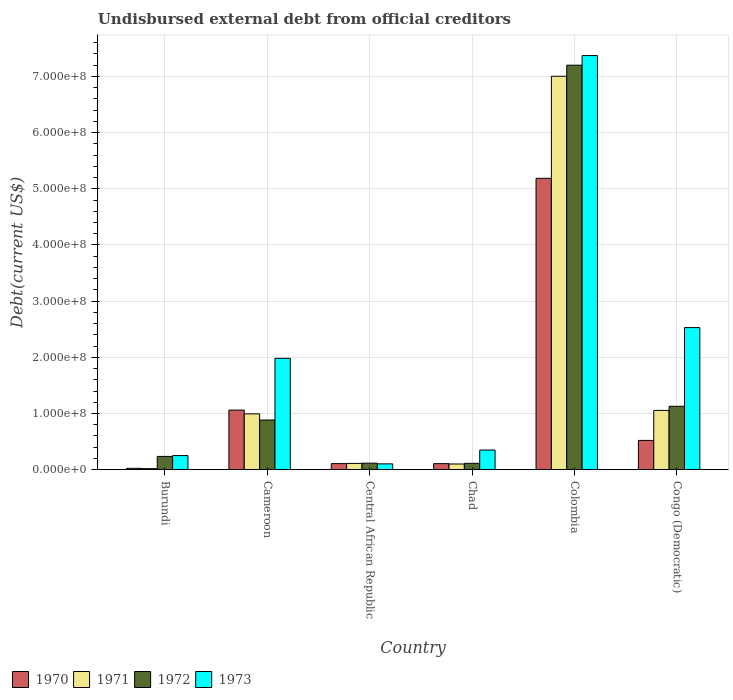How many different coloured bars are there?
Keep it short and to the point. 4. Are the number of bars per tick equal to the number of legend labels?
Your answer should be very brief. Yes. Are the number of bars on each tick of the X-axis equal?
Offer a terse response. Yes. How many bars are there on the 3rd tick from the right?
Your answer should be very brief. 4. What is the label of the 1st group of bars from the left?
Provide a short and direct response. Burundi. What is the total debt in 1972 in Chad?
Provide a succinct answer. 1.14e+07. Across all countries, what is the maximum total debt in 1971?
Your answer should be very brief. 7.00e+08. Across all countries, what is the minimum total debt in 1971?
Provide a short and direct response. 1.93e+06. In which country was the total debt in 1973 maximum?
Offer a terse response. Colombia. In which country was the total debt in 1971 minimum?
Your answer should be compact. Burundi. What is the total total debt in 1972 in the graph?
Your answer should be very brief. 9.68e+08. What is the difference between the total debt in 1972 in Burundi and that in Chad?
Your answer should be compact. 1.23e+07. What is the difference between the total debt in 1972 in Burundi and the total debt in 1973 in Cameroon?
Give a very brief answer. -1.75e+08. What is the average total debt in 1971 per country?
Your answer should be very brief. 1.55e+08. What is the difference between the total debt of/in 1973 and total debt of/in 1970 in Central African Republic?
Offer a terse response. -4.80e+05. In how many countries, is the total debt in 1972 greater than 360000000 US$?
Provide a short and direct response. 1. What is the ratio of the total debt in 1973 in Cameroon to that in Colombia?
Your answer should be compact. 0.27. Is the difference between the total debt in 1973 in Cameroon and Congo (Democratic) greater than the difference between the total debt in 1970 in Cameroon and Congo (Democratic)?
Your answer should be compact. No. What is the difference between the highest and the second highest total debt in 1972?
Offer a very short reply. 6.31e+08. What is the difference between the highest and the lowest total debt in 1973?
Keep it short and to the point. 7.27e+08. In how many countries, is the total debt in 1973 greater than the average total debt in 1973 taken over all countries?
Make the answer very short. 2. Is it the case that in every country, the sum of the total debt in 1973 and total debt in 1971 is greater than the sum of total debt in 1970 and total debt in 1972?
Your answer should be compact. No. Is it the case that in every country, the sum of the total debt in 1971 and total debt in 1973 is greater than the total debt in 1972?
Your answer should be compact. Yes. How many bars are there?
Offer a very short reply. 24. Are the values on the major ticks of Y-axis written in scientific E-notation?
Offer a terse response. Yes. Does the graph contain grids?
Offer a very short reply. Yes. Where does the legend appear in the graph?
Provide a succinct answer. Bottom left. How many legend labels are there?
Keep it short and to the point. 4. How are the legend labels stacked?
Offer a terse response. Horizontal. What is the title of the graph?
Offer a terse response. Undisbursed external debt from official creditors. Does "1973" appear as one of the legend labels in the graph?
Give a very brief answer. Yes. What is the label or title of the X-axis?
Offer a terse response. Country. What is the label or title of the Y-axis?
Ensure brevity in your answer.  Debt(current US$). What is the Debt(current US$) in 1970 in Burundi?
Your response must be concise. 2.42e+06. What is the Debt(current US$) in 1971 in Burundi?
Offer a very short reply. 1.93e+06. What is the Debt(current US$) in 1972 in Burundi?
Provide a succinct answer. 2.37e+07. What is the Debt(current US$) of 1973 in Burundi?
Keep it short and to the point. 2.51e+07. What is the Debt(current US$) in 1970 in Cameroon?
Your response must be concise. 1.06e+08. What is the Debt(current US$) of 1971 in Cameroon?
Your answer should be very brief. 9.94e+07. What is the Debt(current US$) in 1972 in Cameroon?
Provide a succinct answer. 8.84e+07. What is the Debt(current US$) of 1973 in Cameroon?
Offer a terse response. 1.98e+08. What is the Debt(current US$) of 1970 in Central African Republic?
Offer a very short reply. 1.08e+07. What is the Debt(current US$) of 1971 in Central African Republic?
Offer a very short reply. 1.12e+07. What is the Debt(current US$) in 1972 in Central African Republic?
Give a very brief answer. 1.16e+07. What is the Debt(current US$) in 1973 in Central African Republic?
Offer a terse response. 1.04e+07. What is the Debt(current US$) of 1970 in Chad?
Make the answer very short. 1.08e+07. What is the Debt(current US$) in 1971 in Chad?
Your answer should be very brief. 1.02e+07. What is the Debt(current US$) of 1972 in Chad?
Give a very brief answer. 1.14e+07. What is the Debt(current US$) of 1973 in Chad?
Ensure brevity in your answer.  3.50e+07. What is the Debt(current US$) of 1970 in Colombia?
Keep it short and to the point. 5.19e+08. What is the Debt(current US$) of 1971 in Colombia?
Keep it short and to the point. 7.00e+08. What is the Debt(current US$) of 1972 in Colombia?
Keep it short and to the point. 7.20e+08. What is the Debt(current US$) in 1973 in Colombia?
Make the answer very short. 7.37e+08. What is the Debt(current US$) of 1970 in Congo (Democratic)?
Ensure brevity in your answer.  5.21e+07. What is the Debt(current US$) in 1971 in Congo (Democratic)?
Give a very brief answer. 1.06e+08. What is the Debt(current US$) of 1972 in Congo (Democratic)?
Offer a very short reply. 1.13e+08. What is the Debt(current US$) in 1973 in Congo (Democratic)?
Your answer should be compact. 2.53e+08. Across all countries, what is the maximum Debt(current US$) in 1970?
Give a very brief answer. 5.19e+08. Across all countries, what is the maximum Debt(current US$) in 1971?
Your response must be concise. 7.00e+08. Across all countries, what is the maximum Debt(current US$) of 1972?
Keep it short and to the point. 7.20e+08. Across all countries, what is the maximum Debt(current US$) in 1973?
Your answer should be compact. 7.37e+08. Across all countries, what is the minimum Debt(current US$) of 1970?
Make the answer very short. 2.42e+06. Across all countries, what is the minimum Debt(current US$) of 1971?
Offer a terse response. 1.93e+06. Across all countries, what is the minimum Debt(current US$) of 1972?
Provide a short and direct response. 1.14e+07. Across all countries, what is the minimum Debt(current US$) of 1973?
Provide a succinct answer. 1.04e+07. What is the total Debt(current US$) in 1970 in the graph?
Offer a very short reply. 7.01e+08. What is the total Debt(current US$) of 1971 in the graph?
Make the answer very short. 9.28e+08. What is the total Debt(current US$) in 1972 in the graph?
Provide a short and direct response. 9.68e+08. What is the total Debt(current US$) of 1973 in the graph?
Offer a very short reply. 1.26e+09. What is the difference between the Debt(current US$) in 1970 in Burundi and that in Cameroon?
Give a very brief answer. -1.04e+08. What is the difference between the Debt(current US$) in 1971 in Burundi and that in Cameroon?
Offer a very short reply. -9.74e+07. What is the difference between the Debt(current US$) in 1972 in Burundi and that in Cameroon?
Make the answer very short. -6.48e+07. What is the difference between the Debt(current US$) of 1973 in Burundi and that in Cameroon?
Your response must be concise. -1.73e+08. What is the difference between the Debt(current US$) of 1970 in Burundi and that in Central African Republic?
Provide a short and direct response. -8.42e+06. What is the difference between the Debt(current US$) in 1971 in Burundi and that in Central African Republic?
Your answer should be compact. -9.26e+06. What is the difference between the Debt(current US$) in 1972 in Burundi and that in Central African Republic?
Provide a succinct answer. 1.20e+07. What is the difference between the Debt(current US$) in 1973 in Burundi and that in Central African Republic?
Make the answer very short. 1.47e+07. What is the difference between the Debt(current US$) of 1970 in Burundi and that in Chad?
Provide a short and direct response. -8.37e+06. What is the difference between the Debt(current US$) in 1971 in Burundi and that in Chad?
Give a very brief answer. -8.22e+06. What is the difference between the Debt(current US$) in 1972 in Burundi and that in Chad?
Give a very brief answer. 1.23e+07. What is the difference between the Debt(current US$) in 1973 in Burundi and that in Chad?
Provide a succinct answer. -9.88e+06. What is the difference between the Debt(current US$) in 1970 in Burundi and that in Colombia?
Keep it short and to the point. -5.16e+08. What is the difference between the Debt(current US$) in 1971 in Burundi and that in Colombia?
Your response must be concise. -6.98e+08. What is the difference between the Debt(current US$) in 1972 in Burundi and that in Colombia?
Your answer should be very brief. -6.96e+08. What is the difference between the Debt(current US$) in 1973 in Burundi and that in Colombia?
Your answer should be compact. -7.12e+08. What is the difference between the Debt(current US$) of 1970 in Burundi and that in Congo (Democratic)?
Offer a very short reply. -4.97e+07. What is the difference between the Debt(current US$) of 1971 in Burundi and that in Congo (Democratic)?
Your response must be concise. -1.04e+08. What is the difference between the Debt(current US$) of 1972 in Burundi and that in Congo (Democratic)?
Offer a very short reply. -8.92e+07. What is the difference between the Debt(current US$) of 1973 in Burundi and that in Congo (Democratic)?
Offer a terse response. -2.28e+08. What is the difference between the Debt(current US$) of 1970 in Cameroon and that in Central African Republic?
Provide a short and direct response. 9.52e+07. What is the difference between the Debt(current US$) in 1971 in Cameroon and that in Central African Republic?
Your answer should be compact. 8.82e+07. What is the difference between the Debt(current US$) in 1972 in Cameroon and that in Central African Republic?
Make the answer very short. 7.68e+07. What is the difference between the Debt(current US$) of 1973 in Cameroon and that in Central African Republic?
Offer a terse response. 1.88e+08. What is the difference between the Debt(current US$) in 1970 in Cameroon and that in Chad?
Your answer should be compact. 9.53e+07. What is the difference between the Debt(current US$) in 1971 in Cameroon and that in Chad?
Keep it short and to the point. 8.92e+07. What is the difference between the Debt(current US$) of 1972 in Cameroon and that in Chad?
Offer a very short reply. 7.71e+07. What is the difference between the Debt(current US$) in 1973 in Cameroon and that in Chad?
Give a very brief answer. 1.63e+08. What is the difference between the Debt(current US$) of 1970 in Cameroon and that in Colombia?
Your answer should be very brief. -4.12e+08. What is the difference between the Debt(current US$) of 1971 in Cameroon and that in Colombia?
Ensure brevity in your answer.  -6.01e+08. What is the difference between the Debt(current US$) in 1972 in Cameroon and that in Colombia?
Your answer should be compact. -6.31e+08. What is the difference between the Debt(current US$) in 1973 in Cameroon and that in Colombia?
Offer a very short reply. -5.39e+08. What is the difference between the Debt(current US$) of 1970 in Cameroon and that in Congo (Democratic)?
Provide a succinct answer. 5.40e+07. What is the difference between the Debt(current US$) in 1971 in Cameroon and that in Congo (Democratic)?
Keep it short and to the point. -6.17e+06. What is the difference between the Debt(current US$) in 1972 in Cameroon and that in Congo (Democratic)?
Keep it short and to the point. -2.44e+07. What is the difference between the Debt(current US$) in 1973 in Cameroon and that in Congo (Democratic)?
Provide a succinct answer. -5.47e+07. What is the difference between the Debt(current US$) of 1970 in Central African Republic and that in Chad?
Keep it short and to the point. 5.50e+04. What is the difference between the Debt(current US$) in 1971 in Central African Republic and that in Chad?
Keep it short and to the point. 1.04e+06. What is the difference between the Debt(current US$) of 1972 in Central African Republic and that in Chad?
Offer a very short reply. 2.79e+05. What is the difference between the Debt(current US$) of 1973 in Central African Republic and that in Chad?
Offer a very short reply. -2.46e+07. What is the difference between the Debt(current US$) of 1970 in Central African Republic and that in Colombia?
Offer a very short reply. -5.08e+08. What is the difference between the Debt(current US$) of 1971 in Central African Republic and that in Colombia?
Provide a short and direct response. -6.89e+08. What is the difference between the Debt(current US$) of 1972 in Central African Republic and that in Colombia?
Your answer should be compact. -7.08e+08. What is the difference between the Debt(current US$) of 1973 in Central African Republic and that in Colombia?
Provide a succinct answer. -7.27e+08. What is the difference between the Debt(current US$) of 1970 in Central African Republic and that in Congo (Democratic)?
Keep it short and to the point. -4.13e+07. What is the difference between the Debt(current US$) in 1971 in Central African Republic and that in Congo (Democratic)?
Ensure brevity in your answer.  -9.44e+07. What is the difference between the Debt(current US$) in 1972 in Central African Republic and that in Congo (Democratic)?
Your response must be concise. -1.01e+08. What is the difference between the Debt(current US$) of 1973 in Central African Republic and that in Congo (Democratic)?
Offer a very short reply. -2.43e+08. What is the difference between the Debt(current US$) of 1970 in Chad and that in Colombia?
Give a very brief answer. -5.08e+08. What is the difference between the Debt(current US$) in 1971 in Chad and that in Colombia?
Give a very brief answer. -6.90e+08. What is the difference between the Debt(current US$) in 1972 in Chad and that in Colombia?
Your response must be concise. -7.09e+08. What is the difference between the Debt(current US$) of 1973 in Chad and that in Colombia?
Offer a terse response. -7.02e+08. What is the difference between the Debt(current US$) of 1970 in Chad and that in Congo (Democratic)?
Your answer should be compact. -4.13e+07. What is the difference between the Debt(current US$) in 1971 in Chad and that in Congo (Democratic)?
Keep it short and to the point. -9.54e+07. What is the difference between the Debt(current US$) of 1972 in Chad and that in Congo (Democratic)?
Give a very brief answer. -1.02e+08. What is the difference between the Debt(current US$) in 1973 in Chad and that in Congo (Democratic)?
Your answer should be compact. -2.18e+08. What is the difference between the Debt(current US$) in 1970 in Colombia and that in Congo (Democratic)?
Make the answer very short. 4.66e+08. What is the difference between the Debt(current US$) of 1971 in Colombia and that in Congo (Democratic)?
Ensure brevity in your answer.  5.95e+08. What is the difference between the Debt(current US$) in 1972 in Colombia and that in Congo (Democratic)?
Your answer should be compact. 6.07e+08. What is the difference between the Debt(current US$) in 1973 in Colombia and that in Congo (Democratic)?
Offer a terse response. 4.84e+08. What is the difference between the Debt(current US$) of 1970 in Burundi and the Debt(current US$) of 1971 in Cameroon?
Offer a very short reply. -9.69e+07. What is the difference between the Debt(current US$) in 1970 in Burundi and the Debt(current US$) in 1972 in Cameroon?
Ensure brevity in your answer.  -8.60e+07. What is the difference between the Debt(current US$) in 1970 in Burundi and the Debt(current US$) in 1973 in Cameroon?
Your answer should be very brief. -1.96e+08. What is the difference between the Debt(current US$) in 1971 in Burundi and the Debt(current US$) in 1972 in Cameroon?
Your response must be concise. -8.65e+07. What is the difference between the Debt(current US$) of 1971 in Burundi and the Debt(current US$) of 1973 in Cameroon?
Offer a very short reply. -1.96e+08. What is the difference between the Debt(current US$) of 1972 in Burundi and the Debt(current US$) of 1973 in Cameroon?
Make the answer very short. -1.75e+08. What is the difference between the Debt(current US$) in 1970 in Burundi and the Debt(current US$) in 1971 in Central African Republic?
Your response must be concise. -8.77e+06. What is the difference between the Debt(current US$) of 1970 in Burundi and the Debt(current US$) of 1972 in Central African Republic?
Keep it short and to the point. -9.21e+06. What is the difference between the Debt(current US$) in 1970 in Burundi and the Debt(current US$) in 1973 in Central African Republic?
Provide a succinct answer. -7.94e+06. What is the difference between the Debt(current US$) of 1971 in Burundi and the Debt(current US$) of 1972 in Central African Republic?
Keep it short and to the point. -9.71e+06. What is the difference between the Debt(current US$) in 1971 in Burundi and the Debt(current US$) in 1973 in Central African Republic?
Give a very brief answer. -8.44e+06. What is the difference between the Debt(current US$) of 1972 in Burundi and the Debt(current US$) of 1973 in Central African Republic?
Your response must be concise. 1.33e+07. What is the difference between the Debt(current US$) of 1970 in Burundi and the Debt(current US$) of 1971 in Chad?
Provide a short and direct response. -7.73e+06. What is the difference between the Debt(current US$) in 1970 in Burundi and the Debt(current US$) in 1972 in Chad?
Offer a very short reply. -8.93e+06. What is the difference between the Debt(current US$) of 1970 in Burundi and the Debt(current US$) of 1973 in Chad?
Offer a very short reply. -3.26e+07. What is the difference between the Debt(current US$) of 1971 in Burundi and the Debt(current US$) of 1972 in Chad?
Make the answer very short. -9.43e+06. What is the difference between the Debt(current US$) in 1971 in Burundi and the Debt(current US$) in 1973 in Chad?
Your answer should be very brief. -3.31e+07. What is the difference between the Debt(current US$) in 1972 in Burundi and the Debt(current US$) in 1973 in Chad?
Offer a very short reply. -1.13e+07. What is the difference between the Debt(current US$) of 1970 in Burundi and the Debt(current US$) of 1971 in Colombia?
Give a very brief answer. -6.98e+08. What is the difference between the Debt(current US$) in 1970 in Burundi and the Debt(current US$) in 1972 in Colombia?
Ensure brevity in your answer.  -7.18e+08. What is the difference between the Debt(current US$) of 1970 in Burundi and the Debt(current US$) of 1973 in Colombia?
Offer a very short reply. -7.35e+08. What is the difference between the Debt(current US$) in 1971 in Burundi and the Debt(current US$) in 1972 in Colombia?
Offer a very short reply. -7.18e+08. What is the difference between the Debt(current US$) of 1971 in Burundi and the Debt(current US$) of 1973 in Colombia?
Provide a succinct answer. -7.35e+08. What is the difference between the Debt(current US$) in 1972 in Burundi and the Debt(current US$) in 1973 in Colombia?
Offer a terse response. -7.13e+08. What is the difference between the Debt(current US$) of 1970 in Burundi and the Debt(current US$) of 1971 in Congo (Democratic)?
Keep it short and to the point. -1.03e+08. What is the difference between the Debt(current US$) in 1970 in Burundi and the Debt(current US$) in 1972 in Congo (Democratic)?
Make the answer very short. -1.10e+08. What is the difference between the Debt(current US$) in 1970 in Burundi and the Debt(current US$) in 1973 in Congo (Democratic)?
Your answer should be compact. -2.50e+08. What is the difference between the Debt(current US$) in 1971 in Burundi and the Debt(current US$) in 1972 in Congo (Democratic)?
Offer a very short reply. -1.11e+08. What is the difference between the Debt(current US$) of 1971 in Burundi and the Debt(current US$) of 1973 in Congo (Democratic)?
Your answer should be compact. -2.51e+08. What is the difference between the Debt(current US$) in 1972 in Burundi and the Debt(current US$) in 1973 in Congo (Democratic)?
Your response must be concise. -2.29e+08. What is the difference between the Debt(current US$) of 1970 in Cameroon and the Debt(current US$) of 1971 in Central African Republic?
Make the answer very short. 9.49e+07. What is the difference between the Debt(current US$) of 1970 in Cameroon and the Debt(current US$) of 1972 in Central African Republic?
Provide a short and direct response. 9.45e+07. What is the difference between the Debt(current US$) in 1970 in Cameroon and the Debt(current US$) in 1973 in Central African Republic?
Offer a very short reply. 9.57e+07. What is the difference between the Debt(current US$) in 1971 in Cameroon and the Debt(current US$) in 1972 in Central African Republic?
Your answer should be compact. 8.77e+07. What is the difference between the Debt(current US$) in 1971 in Cameroon and the Debt(current US$) in 1973 in Central African Republic?
Your answer should be very brief. 8.90e+07. What is the difference between the Debt(current US$) in 1972 in Cameroon and the Debt(current US$) in 1973 in Central African Republic?
Offer a very short reply. 7.81e+07. What is the difference between the Debt(current US$) of 1970 in Cameroon and the Debt(current US$) of 1971 in Chad?
Your response must be concise. 9.59e+07. What is the difference between the Debt(current US$) of 1970 in Cameroon and the Debt(current US$) of 1972 in Chad?
Give a very brief answer. 9.47e+07. What is the difference between the Debt(current US$) in 1970 in Cameroon and the Debt(current US$) in 1973 in Chad?
Provide a short and direct response. 7.11e+07. What is the difference between the Debt(current US$) in 1971 in Cameroon and the Debt(current US$) in 1972 in Chad?
Your answer should be very brief. 8.80e+07. What is the difference between the Debt(current US$) of 1971 in Cameroon and the Debt(current US$) of 1973 in Chad?
Ensure brevity in your answer.  6.44e+07. What is the difference between the Debt(current US$) of 1972 in Cameroon and the Debt(current US$) of 1973 in Chad?
Offer a very short reply. 5.35e+07. What is the difference between the Debt(current US$) in 1970 in Cameroon and the Debt(current US$) in 1971 in Colombia?
Provide a succinct answer. -5.94e+08. What is the difference between the Debt(current US$) in 1970 in Cameroon and the Debt(current US$) in 1972 in Colombia?
Your answer should be very brief. -6.14e+08. What is the difference between the Debt(current US$) of 1970 in Cameroon and the Debt(current US$) of 1973 in Colombia?
Your answer should be compact. -6.31e+08. What is the difference between the Debt(current US$) of 1971 in Cameroon and the Debt(current US$) of 1972 in Colombia?
Offer a terse response. -6.21e+08. What is the difference between the Debt(current US$) of 1971 in Cameroon and the Debt(current US$) of 1973 in Colombia?
Offer a terse response. -6.38e+08. What is the difference between the Debt(current US$) in 1972 in Cameroon and the Debt(current US$) in 1973 in Colombia?
Ensure brevity in your answer.  -6.49e+08. What is the difference between the Debt(current US$) in 1970 in Cameroon and the Debt(current US$) in 1971 in Congo (Democratic)?
Provide a short and direct response. 5.47e+05. What is the difference between the Debt(current US$) of 1970 in Cameroon and the Debt(current US$) of 1972 in Congo (Democratic)?
Your answer should be compact. -6.78e+06. What is the difference between the Debt(current US$) in 1970 in Cameroon and the Debt(current US$) in 1973 in Congo (Democratic)?
Your answer should be very brief. -1.47e+08. What is the difference between the Debt(current US$) of 1971 in Cameroon and the Debt(current US$) of 1972 in Congo (Democratic)?
Provide a short and direct response. -1.35e+07. What is the difference between the Debt(current US$) in 1971 in Cameroon and the Debt(current US$) in 1973 in Congo (Democratic)?
Your response must be concise. -1.54e+08. What is the difference between the Debt(current US$) of 1972 in Cameroon and the Debt(current US$) of 1973 in Congo (Democratic)?
Keep it short and to the point. -1.64e+08. What is the difference between the Debt(current US$) in 1970 in Central African Republic and the Debt(current US$) in 1971 in Chad?
Keep it short and to the point. 6.94e+05. What is the difference between the Debt(current US$) in 1970 in Central African Republic and the Debt(current US$) in 1972 in Chad?
Your answer should be compact. -5.09e+05. What is the difference between the Debt(current US$) of 1970 in Central African Republic and the Debt(current US$) of 1973 in Chad?
Your answer should be compact. -2.41e+07. What is the difference between the Debt(current US$) of 1971 in Central African Republic and the Debt(current US$) of 1972 in Chad?
Offer a terse response. -1.65e+05. What is the difference between the Debt(current US$) in 1971 in Central African Republic and the Debt(current US$) in 1973 in Chad?
Your response must be concise. -2.38e+07. What is the difference between the Debt(current US$) in 1972 in Central African Republic and the Debt(current US$) in 1973 in Chad?
Ensure brevity in your answer.  -2.34e+07. What is the difference between the Debt(current US$) of 1970 in Central African Republic and the Debt(current US$) of 1971 in Colombia?
Provide a short and direct response. -6.89e+08. What is the difference between the Debt(current US$) of 1970 in Central African Republic and the Debt(current US$) of 1972 in Colombia?
Your answer should be compact. -7.09e+08. What is the difference between the Debt(current US$) of 1970 in Central African Republic and the Debt(current US$) of 1973 in Colombia?
Ensure brevity in your answer.  -7.26e+08. What is the difference between the Debt(current US$) in 1971 in Central African Republic and the Debt(current US$) in 1972 in Colombia?
Give a very brief answer. -7.09e+08. What is the difference between the Debt(current US$) of 1971 in Central African Republic and the Debt(current US$) of 1973 in Colombia?
Make the answer very short. -7.26e+08. What is the difference between the Debt(current US$) of 1972 in Central African Republic and the Debt(current US$) of 1973 in Colombia?
Keep it short and to the point. -7.25e+08. What is the difference between the Debt(current US$) of 1970 in Central African Republic and the Debt(current US$) of 1971 in Congo (Democratic)?
Your answer should be very brief. -9.47e+07. What is the difference between the Debt(current US$) of 1970 in Central African Republic and the Debt(current US$) of 1972 in Congo (Democratic)?
Make the answer very short. -1.02e+08. What is the difference between the Debt(current US$) of 1970 in Central African Republic and the Debt(current US$) of 1973 in Congo (Democratic)?
Give a very brief answer. -2.42e+08. What is the difference between the Debt(current US$) of 1971 in Central African Republic and the Debt(current US$) of 1972 in Congo (Democratic)?
Your answer should be very brief. -1.02e+08. What is the difference between the Debt(current US$) in 1971 in Central African Republic and the Debt(current US$) in 1973 in Congo (Democratic)?
Give a very brief answer. -2.42e+08. What is the difference between the Debt(current US$) of 1972 in Central African Republic and the Debt(current US$) of 1973 in Congo (Democratic)?
Ensure brevity in your answer.  -2.41e+08. What is the difference between the Debt(current US$) in 1970 in Chad and the Debt(current US$) in 1971 in Colombia?
Give a very brief answer. -6.89e+08. What is the difference between the Debt(current US$) of 1970 in Chad and the Debt(current US$) of 1972 in Colombia?
Provide a succinct answer. -7.09e+08. What is the difference between the Debt(current US$) of 1970 in Chad and the Debt(current US$) of 1973 in Colombia?
Your response must be concise. -7.26e+08. What is the difference between the Debt(current US$) in 1971 in Chad and the Debt(current US$) in 1972 in Colombia?
Give a very brief answer. -7.10e+08. What is the difference between the Debt(current US$) of 1971 in Chad and the Debt(current US$) of 1973 in Colombia?
Your answer should be compact. -7.27e+08. What is the difference between the Debt(current US$) in 1972 in Chad and the Debt(current US$) in 1973 in Colombia?
Keep it short and to the point. -7.26e+08. What is the difference between the Debt(current US$) in 1970 in Chad and the Debt(current US$) in 1971 in Congo (Democratic)?
Your answer should be very brief. -9.48e+07. What is the difference between the Debt(current US$) of 1970 in Chad and the Debt(current US$) of 1972 in Congo (Democratic)?
Make the answer very short. -1.02e+08. What is the difference between the Debt(current US$) in 1970 in Chad and the Debt(current US$) in 1973 in Congo (Democratic)?
Make the answer very short. -2.42e+08. What is the difference between the Debt(current US$) of 1971 in Chad and the Debt(current US$) of 1972 in Congo (Democratic)?
Make the answer very short. -1.03e+08. What is the difference between the Debt(current US$) of 1971 in Chad and the Debt(current US$) of 1973 in Congo (Democratic)?
Give a very brief answer. -2.43e+08. What is the difference between the Debt(current US$) in 1972 in Chad and the Debt(current US$) in 1973 in Congo (Democratic)?
Your answer should be very brief. -2.42e+08. What is the difference between the Debt(current US$) of 1970 in Colombia and the Debt(current US$) of 1971 in Congo (Democratic)?
Your response must be concise. 4.13e+08. What is the difference between the Debt(current US$) of 1970 in Colombia and the Debt(current US$) of 1972 in Congo (Democratic)?
Provide a succinct answer. 4.06e+08. What is the difference between the Debt(current US$) of 1970 in Colombia and the Debt(current US$) of 1973 in Congo (Democratic)?
Your response must be concise. 2.66e+08. What is the difference between the Debt(current US$) in 1971 in Colombia and the Debt(current US$) in 1972 in Congo (Democratic)?
Offer a very short reply. 5.87e+08. What is the difference between the Debt(current US$) in 1971 in Colombia and the Debt(current US$) in 1973 in Congo (Democratic)?
Give a very brief answer. 4.47e+08. What is the difference between the Debt(current US$) of 1972 in Colombia and the Debt(current US$) of 1973 in Congo (Democratic)?
Give a very brief answer. 4.67e+08. What is the average Debt(current US$) in 1970 per country?
Your answer should be very brief. 1.17e+08. What is the average Debt(current US$) in 1971 per country?
Keep it short and to the point. 1.55e+08. What is the average Debt(current US$) in 1972 per country?
Your answer should be very brief. 1.61e+08. What is the average Debt(current US$) of 1973 per country?
Your answer should be very brief. 2.10e+08. What is the difference between the Debt(current US$) in 1970 and Debt(current US$) in 1971 in Burundi?
Make the answer very short. 4.96e+05. What is the difference between the Debt(current US$) in 1970 and Debt(current US$) in 1972 in Burundi?
Offer a terse response. -2.12e+07. What is the difference between the Debt(current US$) in 1970 and Debt(current US$) in 1973 in Burundi?
Your response must be concise. -2.27e+07. What is the difference between the Debt(current US$) of 1971 and Debt(current US$) of 1972 in Burundi?
Provide a short and direct response. -2.17e+07. What is the difference between the Debt(current US$) of 1971 and Debt(current US$) of 1973 in Burundi?
Your answer should be very brief. -2.32e+07. What is the difference between the Debt(current US$) in 1972 and Debt(current US$) in 1973 in Burundi?
Your answer should be compact. -1.45e+06. What is the difference between the Debt(current US$) in 1970 and Debt(current US$) in 1971 in Cameroon?
Give a very brief answer. 6.72e+06. What is the difference between the Debt(current US$) of 1970 and Debt(current US$) of 1972 in Cameroon?
Ensure brevity in your answer.  1.76e+07. What is the difference between the Debt(current US$) of 1970 and Debt(current US$) of 1973 in Cameroon?
Your answer should be very brief. -9.21e+07. What is the difference between the Debt(current US$) in 1971 and Debt(current US$) in 1972 in Cameroon?
Offer a very short reply. 1.09e+07. What is the difference between the Debt(current US$) of 1971 and Debt(current US$) of 1973 in Cameroon?
Your answer should be very brief. -9.88e+07. What is the difference between the Debt(current US$) in 1972 and Debt(current US$) in 1973 in Cameroon?
Your response must be concise. -1.10e+08. What is the difference between the Debt(current US$) in 1970 and Debt(current US$) in 1971 in Central African Republic?
Make the answer very short. -3.44e+05. What is the difference between the Debt(current US$) of 1970 and Debt(current US$) of 1972 in Central African Republic?
Your response must be concise. -7.88e+05. What is the difference between the Debt(current US$) of 1971 and Debt(current US$) of 1972 in Central African Republic?
Offer a terse response. -4.44e+05. What is the difference between the Debt(current US$) of 1971 and Debt(current US$) of 1973 in Central African Republic?
Give a very brief answer. 8.24e+05. What is the difference between the Debt(current US$) of 1972 and Debt(current US$) of 1973 in Central African Republic?
Offer a very short reply. 1.27e+06. What is the difference between the Debt(current US$) of 1970 and Debt(current US$) of 1971 in Chad?
Give a very brief answer. 6.39e+05. What is the difference between the Debt(current US$) of 1970 and Debt(current US$) of 1972 in Chad?
Offer a very short reply. -5.64e+05. What is the difference between the Debt(current US$) in 1970 and Debt(current US$) in 1973 in Chad?
Ensure brevity in your answer.  -2.42e+07. What is the difference between the Debt(current US$) in 1971 and Debt(current US$) in 1972 in Chad?
Provide a short and direct response. -1.20e+06. What is the difference between the Debt(current US$) of 1971 and Debt(current US$) of 1973 in Chad?
Provide a short and direct response. -2.48e+07. What is the difference between the Debt(current US$) of 1972 and Debt(current US$) of 1973 in Chad?
Offer a terse response. -2.36e+07. What is the difference between the Debt(current US$) of 1970 and Debt(current US$) of 1971 in Colombia?
Give a very brief answer. -1.82e+08. What is the difference between the Debt(current US$) of 1970 and Debt(current US$) of 1972 in Colombia?
Offer a very short reply. -2.01e+08. What is the difference between the Debt(current US$) of 1970 and Debt(current US$) of 1973 in Colombia?
Your answer should be very brief. -2.18e+08. What is the difference between the Debt(current US$) in 1971 and Debt(current US$) in 1972 in Colombia?
Make the answer very short. -1.97e+07. What is the difference between the Debt(current US$) in 1971 and Debt(current US$) in 1973 in Colombia?
Offer a very short reply. -3.68e+07. What is the difference between the Debt(current US$) of 1972 and Debt(current US$) of 1973 in Colombia?
Your answer should be compact. -1.71e+07. What is the difference between the Debt(current US$) in 1970 and Debt(current US$) in 1971 in Congo (Democratic)?
Make the answer very short. -5.34e+07. What is the difference between the Debt(current US$) in 1970 and Debt(current US$) in 1972 in Congo (Democratic)?
Keep it short and to the point. -6.07e+07. What is the difference between the Debt(current US$) of 1970 and Debt(current US$) of 1973 in Congo (Democratic)?
Your answer should be compact. -2.01e+08. What is the difference between the Debt(current US$) in 1971 and Debt(current US$) in 1972 in Congo (Democratic)?
Give a very brief answer. -7.32e+06. What is the difference between the Debt(current US$) in 1971 and Debt(current US$) in 1973 in Congo (Democratic)?
Your answer should be very brief. -1.47e+08. What is the difference between the Debt(current US$) of 1972 and Debt(current US$) of 1973 in Congo (Democratic)?
Provide a short and direct response. -1.40e+08. What is the ratio of the Debt(current US$) in 1970 in Burundi to that in Cameroon?
Offer a very short reply. 0.02. What is the ratio of the Debt(current US$) of 1971 in Burundi to that in Cameroon?
Your response must be concise. 0.02. What is the ratio of the Debt(current US$) in 1972 in Burundi to that in Cameroon?
Your response must be concise. 0.27. What is the ratio of the Debt(current US$) of 1973 in Burundi to that in Cameroon?
Your answer should be very brief. 0.13. What is the ratio of the Debt(current US$) in 1970 in Burundi to that in Central African Republic?
Ensure brevity in your answer.  0.22. What is the ratio of the Debt(current US$) in 1971 in Burundi to that in Central African Republic?
Your answer should be compact. 0.17. What is the ratio of the Debt(current US$) in 1972 in Burundi to that in Central African Republic?
Give a very brief answer. 2.03. What is the ratio of the Debt(current US$) in 1973 in Burundi to that in Central African Republic?
Your answer should be compact. 2.42. What is the ratio of the Debt(current US$) in 1970 in Burundi to that in Chad?
Offer a very short reply. 0.22. What is the ratio of the Debt(current US$) in 1971 in Burundi to that in Chad?
Make the answer very short. 0.19. What is the ratio of the Debt(current US$) of 1972 in Burundi to that in Chad?
Offer a terse response. 2.08. What is the ratio of the Debt(current US$) of 1973 in Burundi to that in Chad?
Your response must be concise. 0.72. What is the ratio of the Debt(current US$) in 1970 in Burundi to that in Colombia?
Ensure brevity in your answer.  0. What is the ratio of the Debt(current US$) in 1971 in Burundi to that in Colombia?
Offer a terse response. 0. What is the ratio of the Debt(current US$) of 1972 in Burundi to that in Colombia?
Your response must be concise. 0.03. What is the ratio of the Debt(current US$) in 1973 in Burundi to that in Colombia?
Offer a terse response. 0.03. What is the ratio of the Debt(current US$) in 1970 in Burundi to that in Congo (Democratic)?
Ensure brevity in your answer.  0.05. What is the ratio of the Debt(current US$) in 1971 in Burundi to that in Congo (Democratic)?
Ensure brevity in your answer.  0.02. What is the ratio of the Debt(current US$) in 1972 in Burundi to that in Congo (Democratic)?
Ensure brevity in your answer.  0.21. What is the ratio of the Debt(current US$) in 1973 in Burundi to that in Congo (Democratic)?
Your answer should be compact. 0.1. What is the ratio of the Debt(current US$) of 1970 in Cameroon to that in Central African Republic?
Your response must be concise. 9.78. What is the ratio of the Debt(current US$) in 1971 in Cameroon to that in Central African Republic?
Ensure brevity in your answer.  8.88. What is the ratio of the Debt(current US$) in 1972 in Cameroon to that in Central African Republic?
Provide a short and direct response. 7.6. What is the ratio of the Debt(current US$) of 1973 in Cameroon to that in Central African Republic?
Keep it short and to the point. 19.11. What is the ratio of the Debt(current US$) of 1970 in Cameroon to that in Chad?
Offer a terse response. 9.83. What is the ratio of the Debt(current US$) in 1971 in Cameroon to that in Chad?
Offer a very short reply. 9.79. What is the ratio of the Debt(current US$) of 1972 in Cameroon to that in Chad?
Offer a very short reply. 7.79. What is the ratio of the Debt(current US$) in 1973 in Cameroon to that in Chad?
Give a very brief answer. 5.66. What is the ratio of the Debt(current US$) in 1970 in Cameroon to that in Colombia?
Your answer should be very brief. 0.2. What is the ratio of the Debt(current US$) of 1971 in Cameroon to that in Colombia?
Keep it short and to the point. 0.14. What is the ratio of the Debt(current US$) in 1972 in Cameroon to that in Colombia?
Give a very brief answer. 0.12. What is the ratio of the Debt(current US$) in 1973 in Cameroon to that in Colombia?
Keep it short and to the point. 0.27. What is the ratio of the Debt(current US$) of 1970 in Cameroon to that in Congo (Democratic)?
Offer a terse response. 2.04. What is the ratio of the Debt(current US$) of 1971 in Cameroon to that in Congo (Democratic)?
Your response must be concise. 0.94. What is the ratio of the Debt(current US$) of 1972 in Cameroon to that in Congo (Democratic)?
Your answer should be compact. 0.78. What is the ratio of the Debt(current US$) of 1973 in Cameroon to that in Congo (Democratic)?
Make the answer very short. 0.78. What is the ratio of the Debt(current US$) of 1971 in Central African Republic to that in Chad?
Offer a very short reply. 1.1. What is the ratio of the Debt(current US$) in 1972 in Central African Republic to that in Chad?
Provide a short and direct response. 1.02. What is the ratio of the Debt(current US$) of 1973 in Central African Republic to that in Chad?
Provide a short and direct response. 0.3. What is the ratio of the Debt(current US$) of 1970 in Central African Republic to that in Colombia?
Your response must be concise. 0.02. What is the ratio of the Debt(current US$) of 1971 in Central African Republic to that in Colombia?
Your response must be concise. 0.02. What is the ratio of the Debt(current US$) of 1972 in Central African Republic to that in Colombia?
Provide a succinct answer. 0.02. What is the ratio of the Debt(current US$) of 1973 in Central African Republic to that in Colombia?
Your answer should be very brief. 0.01. What is the ratio of the Debt(current US$) in 1970 in Central African Republic to that in Congo (Democratic)?
Give a very brief answer. 0.21. What is the ratio of the Debt(current US$) in 1971 in Central African Republic to that in Congo (Democratic)?
Provide a succinct answer. 0.11. What is the ratio of the Debt(current US$) in 1972 in Central African Republic to that in Congo (Democratic)?
Your response must be concise. 0.1. What is the ratio of the Debt(current US$) in 1973 in Central African Republic to that in Congo (Democratic)?
Offer a terse response. 0.04. What is the ratio of the Debt(current US$) of 1970 in Chad to that in Colombia?
Keep it short and to the point. 0.02. What is the ratio of the Debt(current US$) of 1971 in Chad to that in Colombia?
Provide a short and direct response. 0.01. What is the ratio of the Debt(current US$) of 1972 in Chad to that in Colombia?
Provide a succinct answer. 0.02. What is the ratio of the Debt(current US$) of 1973 in Chad to that in Colombia?
Provide a short and direct response. 0.05. What is the ratio of the Debt(current US$) in 1970 in Chad to that in Congo (Democratic)?
Ensure brevity in your answer.  0.21. What is the ratio of the Debt(current US$) in 1971 in Chad to that in Congo (Democratic)?
Provide a short and direct response. 0.1. What is the ratio of the Debt(current US$) in 1972 in Chad to that in Congo (Democratic)?
Make the answer very short. 0.1. What is the ratio of the Debt(current US$) of 1973 in Chad to that in Congo (Democratic)?
Make the answer very short. 0.14. What is the ratio of the Debt(current US$) of 1970 in Colombia to that in Congo (Democratic)?
Your response must be concise. 9.95. What is the ratio of the Debt(current US$) of 1971 in Colombia to that in Congo (Democratic)?
Provide a short and direct response. 6.63. What is the ratio of the Debt(current US$) of 1972 in Colombia to that in Congo (Democratic)?
Provide a short and direct response. 6.38. What is the ratio of the Debt(current US$) in 1973 in Colombia to that in Congo (Democratic)?
Offer a terse response. 2.91. What is the difference between the highest and the second highest Debt(current US$) of 1970?
Offer a very short reply. 4.12e+08. What is the difference between the highest and the second highest Debt(current US$) in 1971?
Ensure brevity in your answer.  5.95e+08. What is the difference between the highest and the second highest Debt(current US$) in 1972?
Your answer should be very brief. 6.07e+08. What is the difference between the highest and the second highest Debt(current US$) of 1973?
Your answer should be compact. 4.84e+08. What is the difference between the highest and the lowest Debt(current US$) in 1970?
Give a very brief answer. 5.16e+08. What is the difference between the highest and the lowest Debt(current US$) in 1971?
Keep it short and to the point. 6.98e+08. What is the difference between the highest and the lowest Debt(current US$) in 1972?
Offer a very short reply. 7.09e+08. What is the difference between the highest and the lowest Debt(current US$) of 1973?
Offer a very short reply. 7.27e+08. 